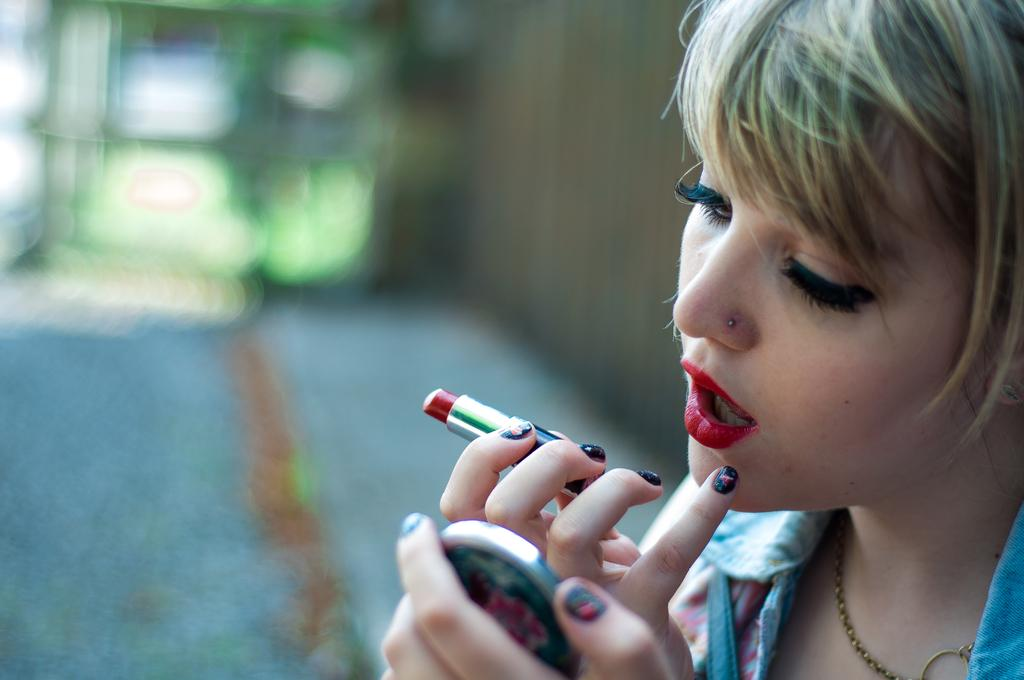Who is the main subject in the image? There is a woman in the image. What is the woman holding in one hand? The woman is holding a lipstick in one hand. What is the woman holding in her other hand? There is an object in the other hand of the woman. Can you describe the background of the image? The background of the image is blurred. What type of leather is visible on the peace symbol in the image? There is no leather or peace symbol present in the image. 